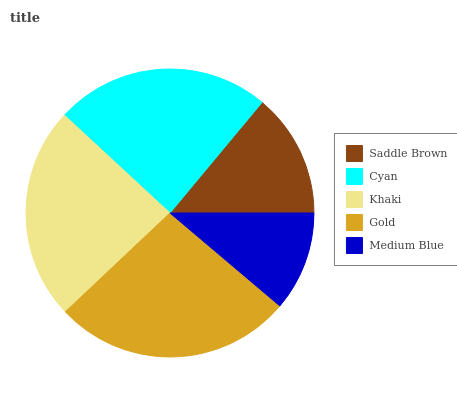Is Medium Blue the minimum?
Answer yes or no. Yes. Is Gold the maximum?
Answer yes or no. Yes. Is Cyan the minimum?
Answer yes or no. No. Is Cyan the maximum?
Answer yes or no. No. Is Cyan greater than Saddle Brown?
Answer yes or no. Yes. Is Saddle Brown less than Cyan?
Answer yes or no. Yes. Is Saddle Brown greater than Cyan?
Answer yes or no. No. Is Cyan less than Saddle Brown?
Answer yes or no. No. Is Khaki the high median?
Answer yes or no. Yes. Is Khaki the low median?
Answer yes or no. Yes. Is Medium Blue the high median?
Answer yes or no. No. Is Gold the low median?
Answer yes or no. No. 